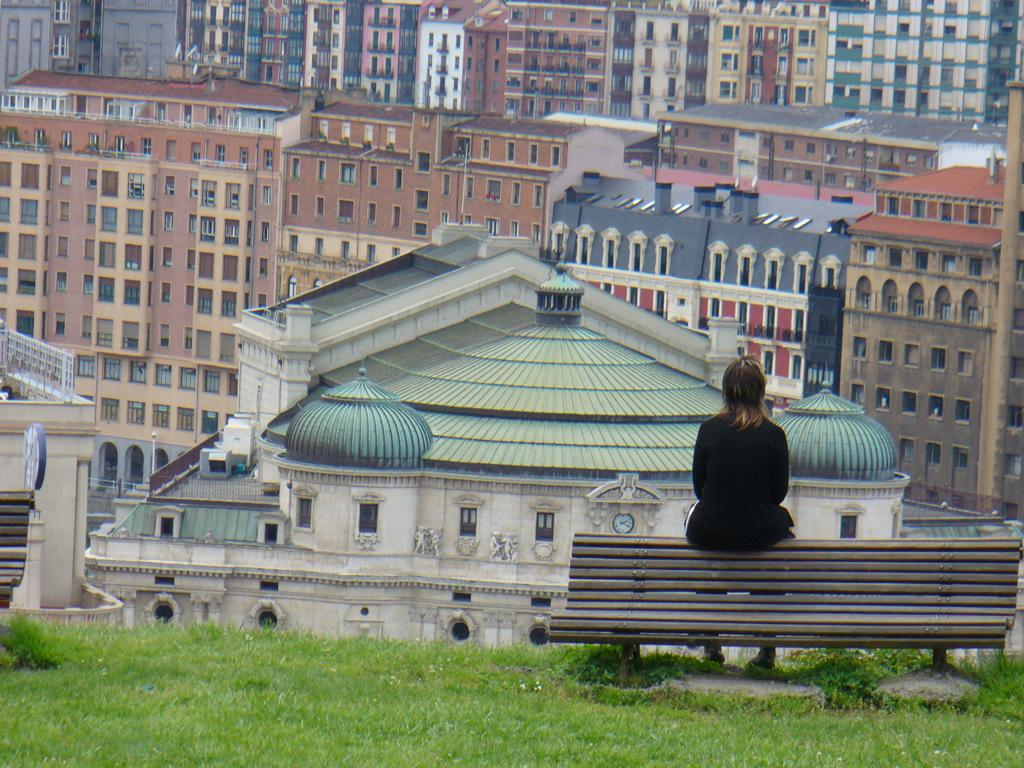What is the woman in the image doing? The woman is sitting on a bench in the image. What can be seen in the background of the image? There are buildings visible in the image. What type of terrain is present in the image? There is grass present in the image. What kind of view does the image provide? The image appears to be a hilltop view. What type of bird can be seen singing on the lock in the image? There is no bird or lock present in the image; it features a woman sitting on a bench with a background of buildings and grass. 